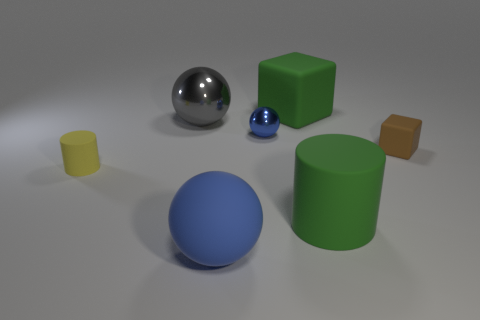The metal thing that is the same color as the matte sphere is what shape?
Ensure brevity in your answer.  Sphere. The thing that is the same color as the matte sphere is what size?
Make the answer very short. Small. Are there an equal number of green rubber blocks on the right side of the green matte cylinder and large objects behind the blue rubber object?
Ensure brevity in your answer.  No. How many other things are there of the same shape as the brown rubber thing?
Provide a short and direct response. 1. Do the cylinder that is to the left of the green matte block and the blue object that is behind the big blue thing have the same size?
Your answer should be compact. Yes. What number of blocks are either tiny blue metal things or small things?
Your response must be concise. 1. What number of rubber things are tiny yellow objects or green cylinders?
Give a very brief answer. 2. What is the size of the other rubber thing that is the same shape as the brown matte object?
Keep it short and to the point. Large. Is there any other thing that is the same size as the yellow object?
Make the answer very short. Yes. There is a rubber sphere; is it the same size as the matte object that is right of the green rubber cylinder?
Provide a succinct answer. No. 